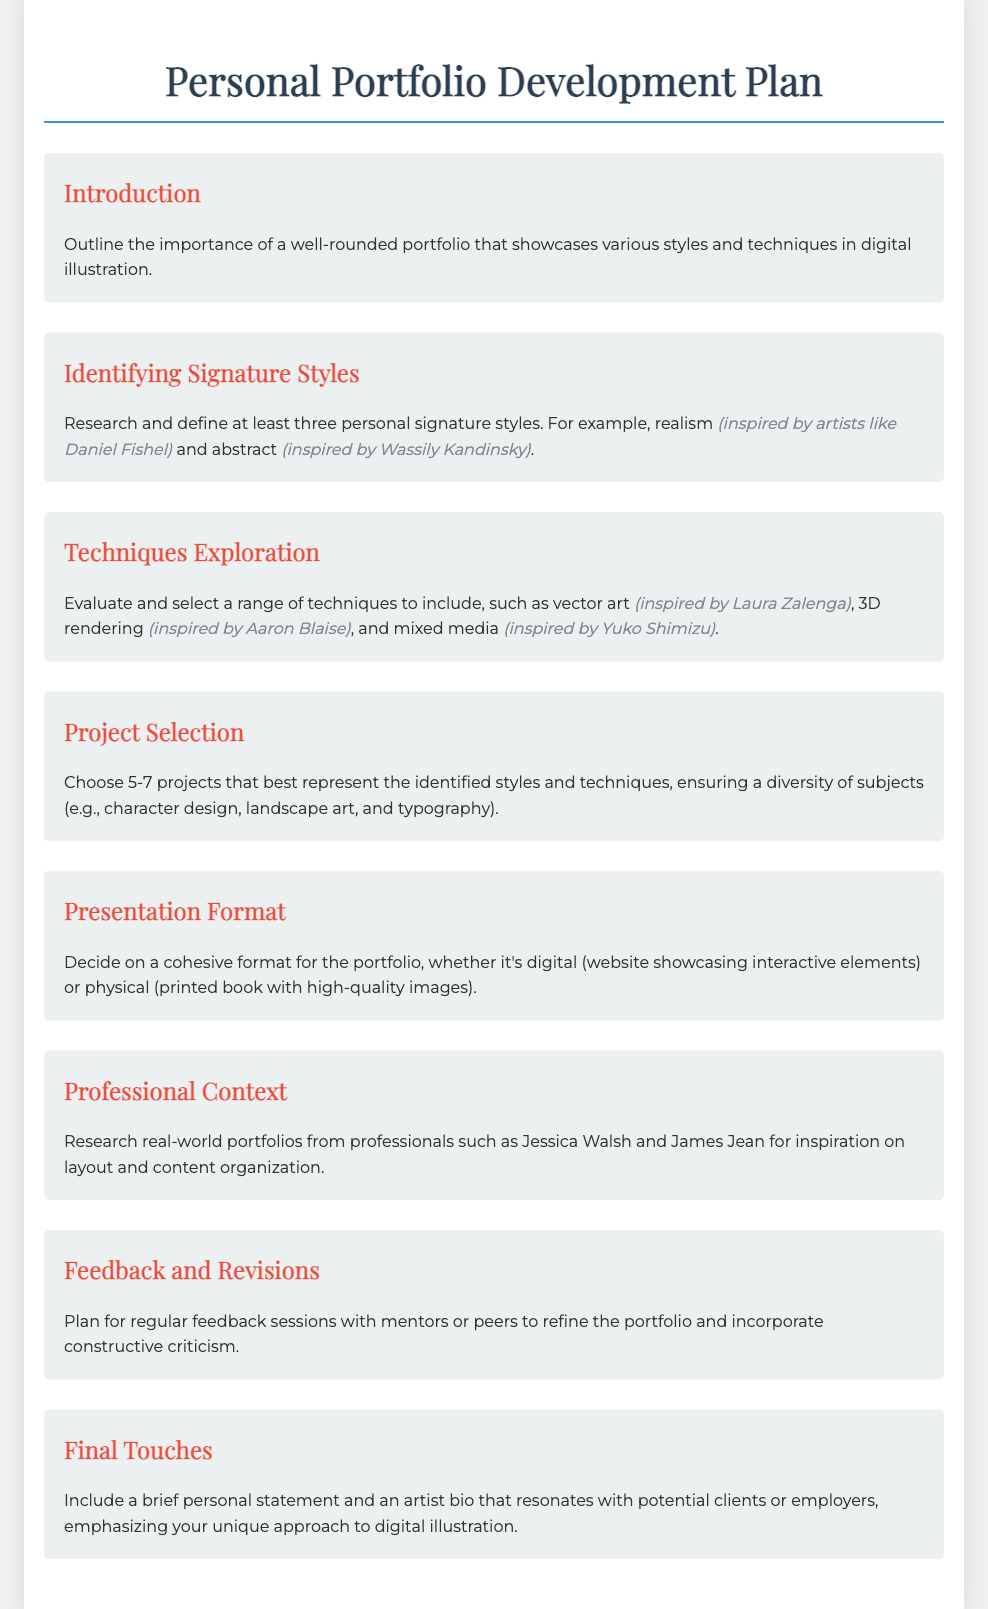What is the title of the document? The title of the document is found in the header section, which presents the overall subject matter of the content.
Answer: Personal Portfolio Development Plan How many personal signature styles should be defined? The document specifies a quantity of personal signature styles to be researched and defined in the section.
Answer: Three Who is mentioned as an inspiration for the realism style? The artist associated with the realism style is indicated within the respective section as an example of inspiration.
Answer: Daniel Fishel What types of projects should be selected for the portfolio? The document indicates the types of projects to choose, ensuring a variety of subjects for representation.
Answer: 5-7 Which technique is inspired by Yuko Shimizu? The document lists various techniques, specifying one that is influenced by a prominent artist.
Answer: Mixed media What is a recommended resource for layout inspiration? The document advises researching real-world portfolios from well-known professionals to gather ideas for presentation.
Answer: Jessica Walsh What should be included in the final touches section? The final touches section emphasizes the final components necessary to enhance the overall portfolio presentation.
Answer: Personal statement and artist bio 